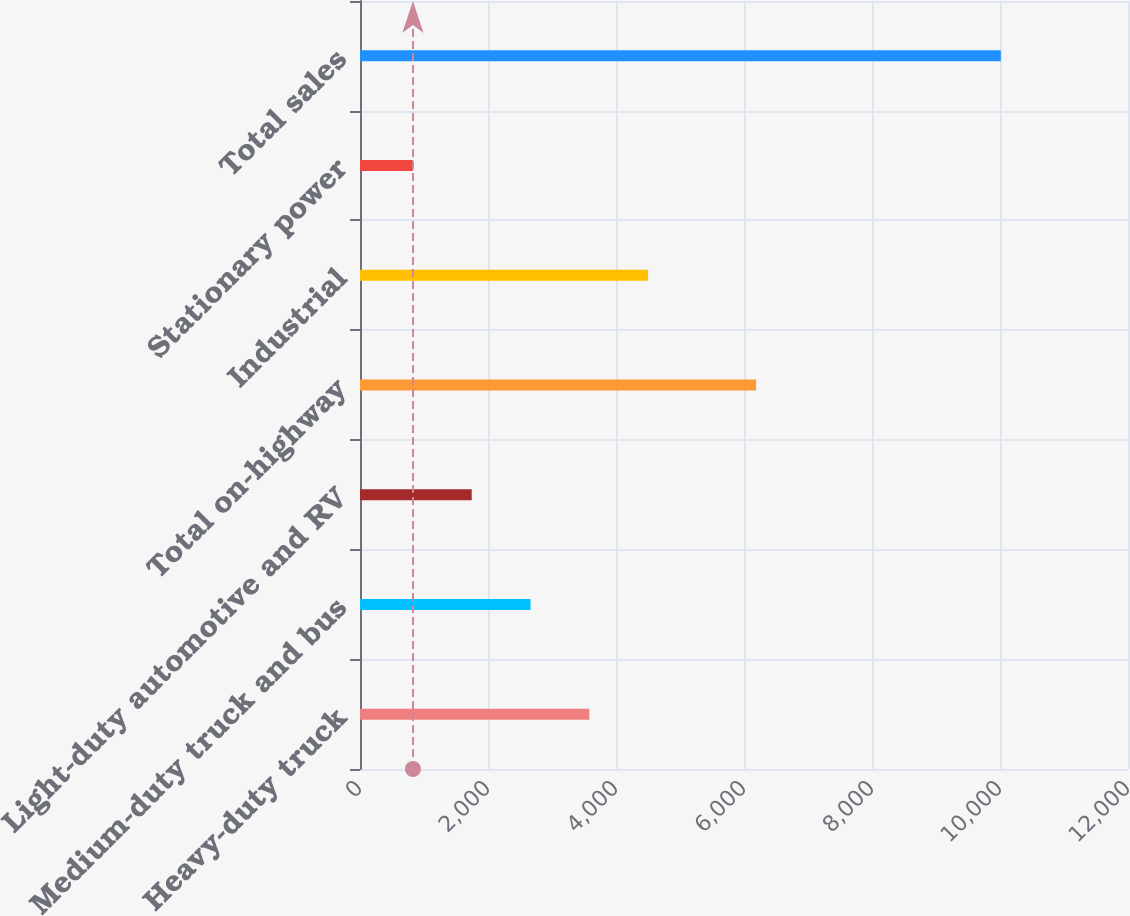Convert chart. <chart><loc_0><loc_0><loc_500><loc_500><bar_chart><fcel>Heavy-duty truck<fcel>Medium-duty truck and bus<fcel>Light-duty automotive and RV<fcel>Total on-highway<fcel>Industrial<fcel>Stationary power<fcel>Total sales<nl><fcel>3582.8<fcel>2664.2<fcel>1745.6<fcel>6190<fcel>4501.4<fcel>827<fcel>10013<nl></chart> 